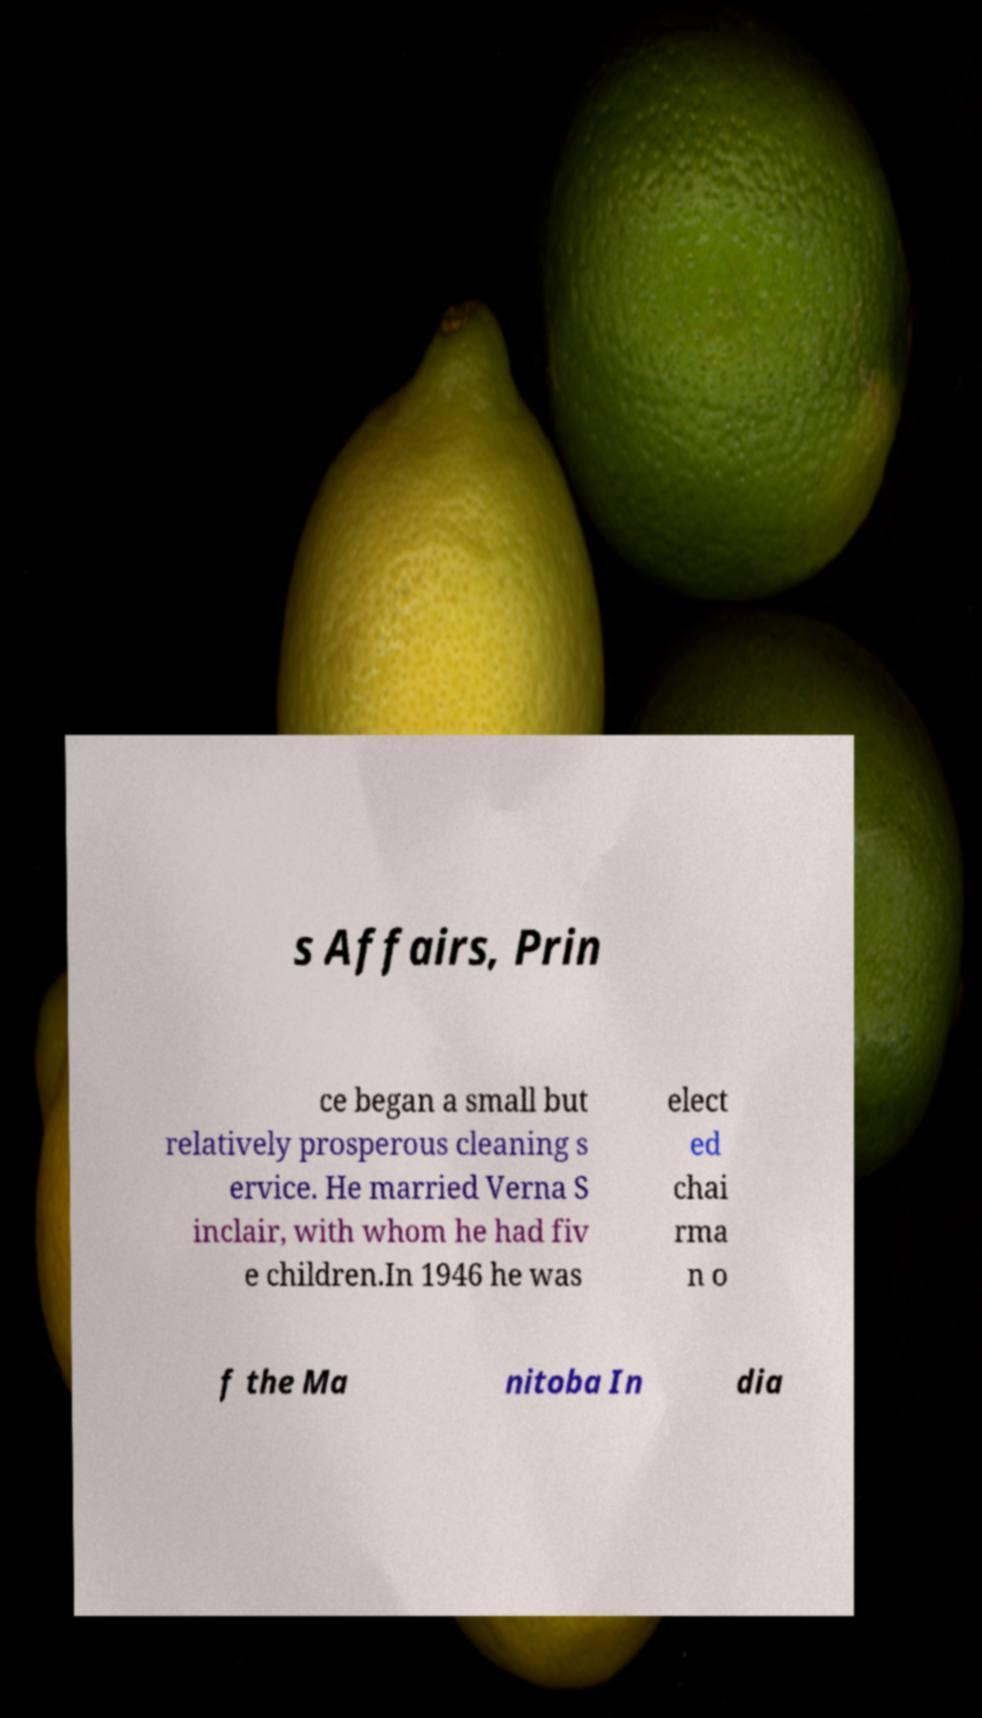There's text embedded in this image that I need extracted. Can you transcribe it verbatim? s Affairs, Prin ce began a small but relatively prosperous cleaning s ervice. He married Verna S inclair, with whom he had fiv e children.In 1946 he was elect ed chai rma n o f the Ma nitoba In dia 